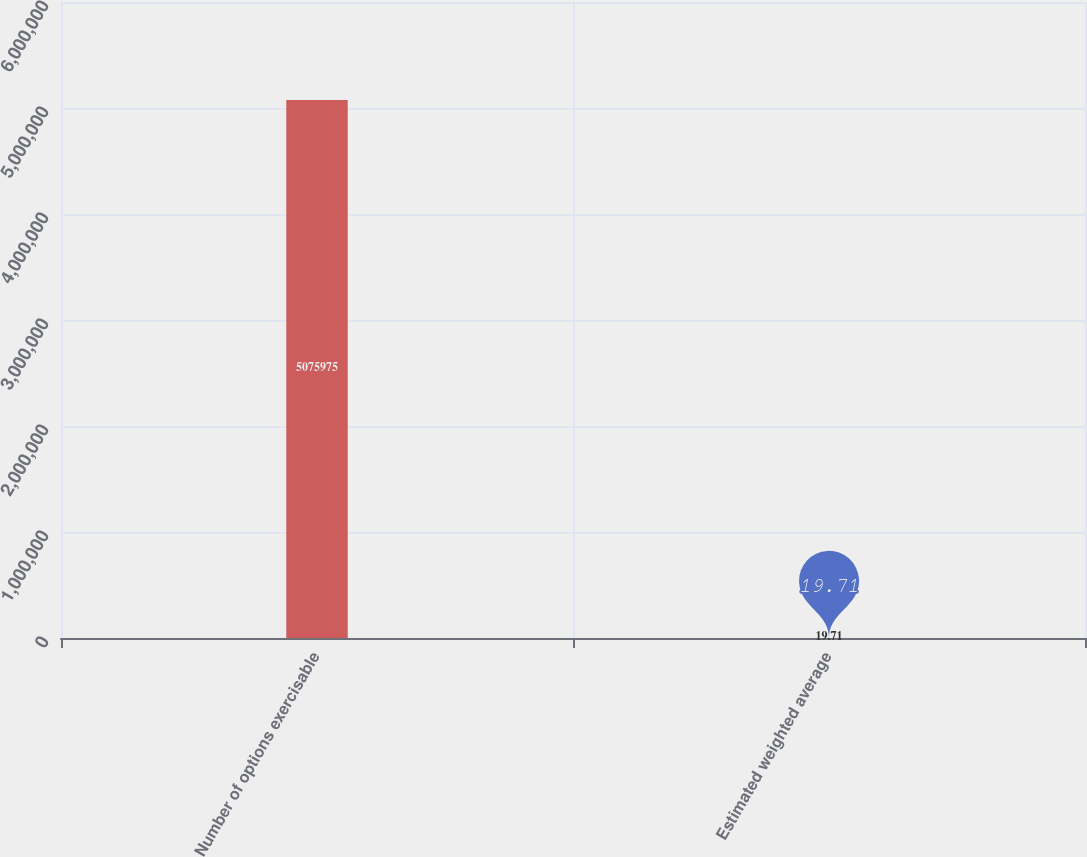<chart> <loc_0><loc_0><loc_500><loc_500><bar_chart><fcel>Number of options exercisable<fcel>Estimated weighted average<nl><fcel>5.07598e+06<fcel>19.71<nl></chart> 